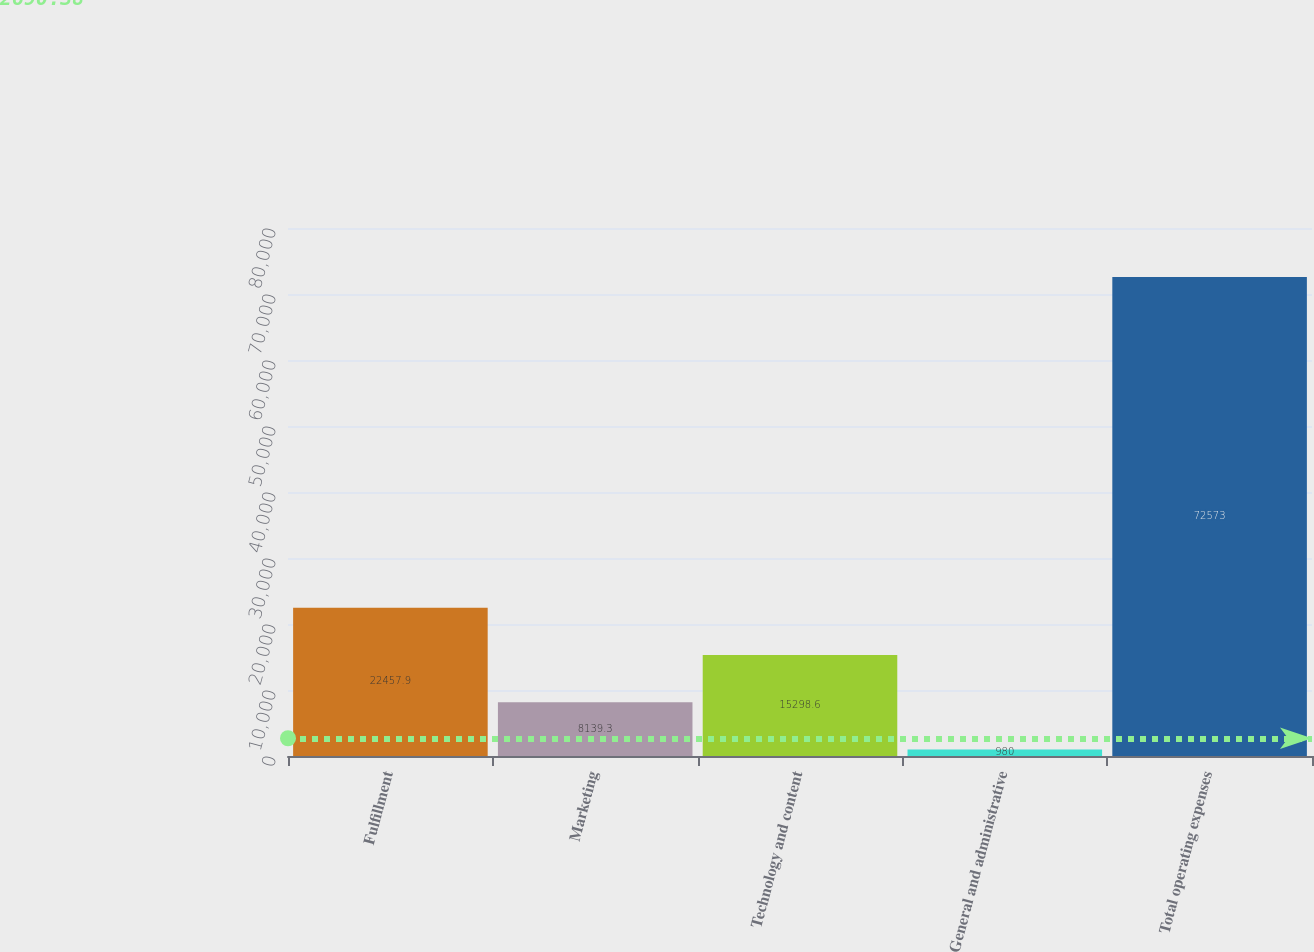Convert chart. <chart><loc_0><loc_0><loc_500><loc_500><bar_chart><fcel>Fulfillment<fcel>Marketing<fcel>Technology and content<fcel>General and administrative<fcel>Total operating expenses<nl><fcel>22457.9<fcel>8139.3<fcel>15298.6<fcel>980<fcel>72573<nl></chart> 